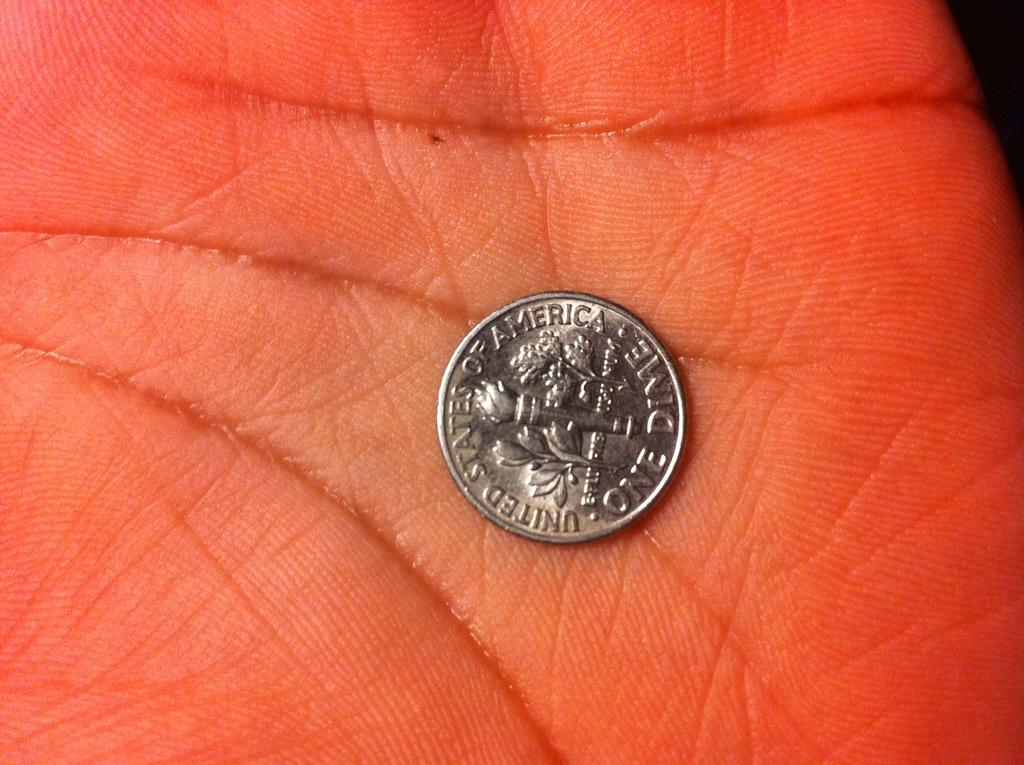<image>
Present a compact description of the photo's key features. Person holding a silver coin that says United States Of America on it. 